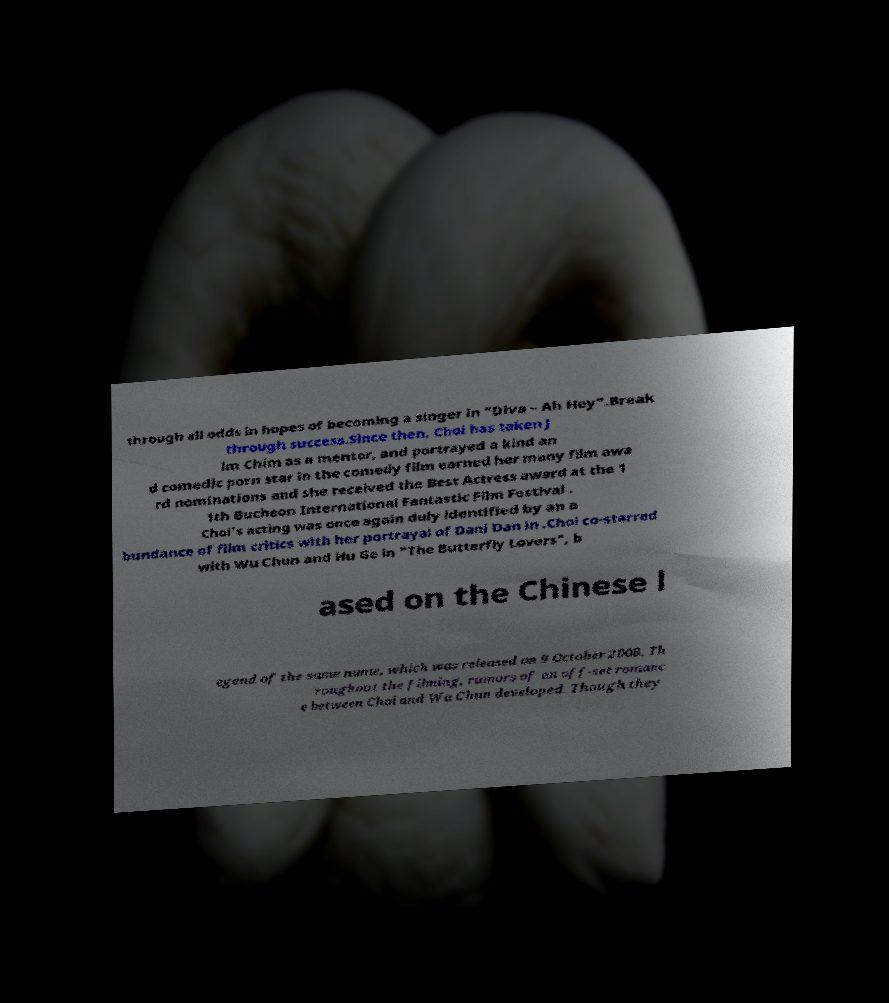For documentation purposes, I need the text within this image transcribed. Could you provide that? through all odds in hopes of becoming a singer in "Diva – Ah Hey".Break through success.Since then, Choi has taken J im Chim as a mentor, and portrayed a kind an d comedic porn star in the comedy film earned her many film awa rd nominations and she received the Best Actress award at the 1 1th Bucheon International Fantastic Film Festival . Choi's acting was once again duly identified by an a bundance of film critics with her portrayal of Dani Dan in .Choi co-starred with Wu Chun and Hu Ge in "The Butterfly Lovers", b ased on the Chinese l egend of the same name, which was released on 9 October 2008. Th roughout the filming, rumors of an off-set romanc e between Choi and Wu Chun developed. Though they 